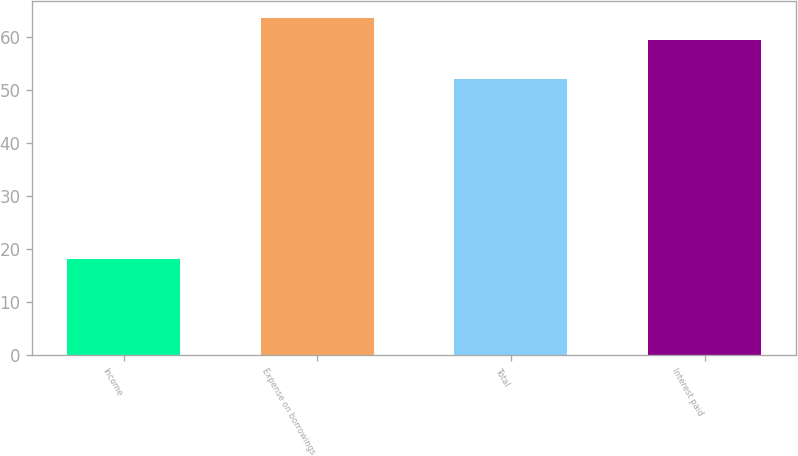Convert chart. <chart><loc_0><loc_0><loc_500><loc_500><bar_chart><fcel>Income<fcel>Expense on borrowings<fcel>Total<fcel>Interest paid<nl><fcel>18.1<fcel>63.69<fcel>52.2<fcel>59.5<nl></chart> 